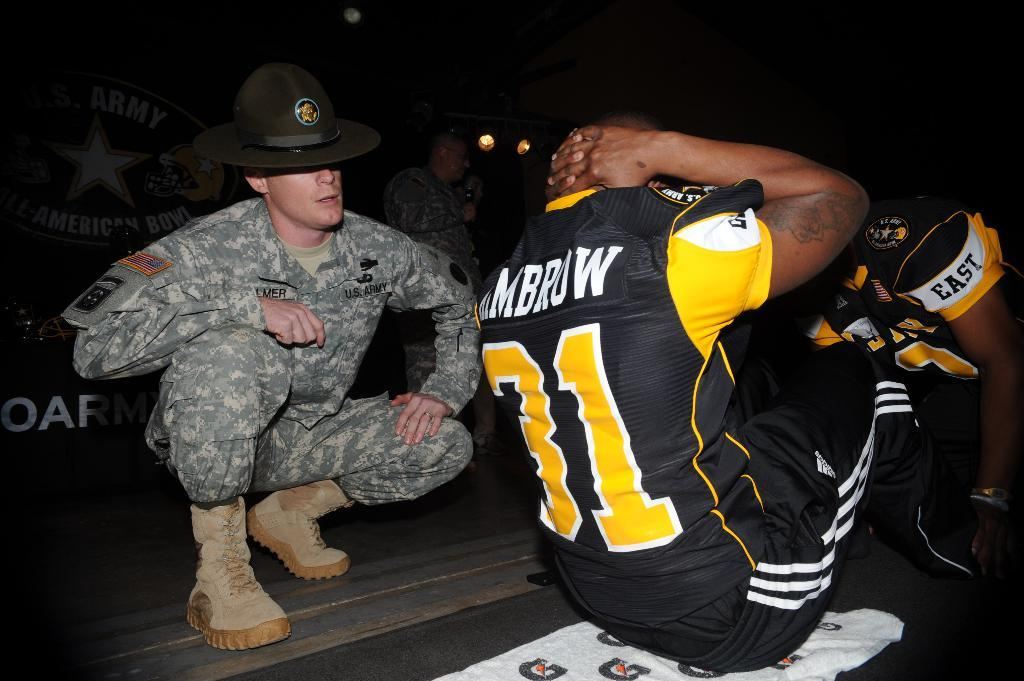<image>
Render a clear and concise summary of the photo. A football player from East helps another player do sit-ups. 